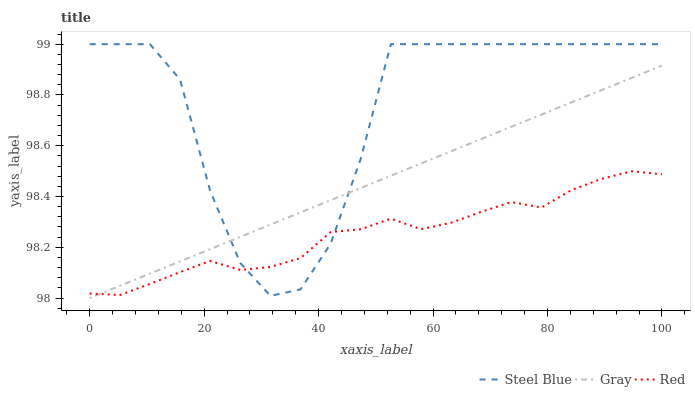Does Red have the minimum area under the curve?
Answer yes or no. Yes. Does Steel Blue have the maximum area under the curve?
Answer yes or no. Yes. Does Steel Blue have the minimum area under the curve?
Answer yes or no. No. Does Red have the maximum area under the curve?
Answer yes or no. No. Is Gray the smoothest?
Answer yes or no. Yes. Is Steel Blue the roughest?
Answer yes or no. Yes. Is Red the smoothest?
Answer yes or no. No. Is Red the roughest?
Answer yes or no. No. Does Gray have the lowest value?
Answer yes or no. Yes. Does Steel Blue have the lowest value?
Answer yes or no. No. Does Steel Blue have the highest value?
Answer yes or no. Yes. Does Red have the highest value?
Answer yes or no. No. Does Steel Blue intersect Red?
Answer yes or no. Yes. Is Steel Blue less than Red?
Answer yes or no. No. Is Steel Blue greater than Red?
Answer yes or no. No. 